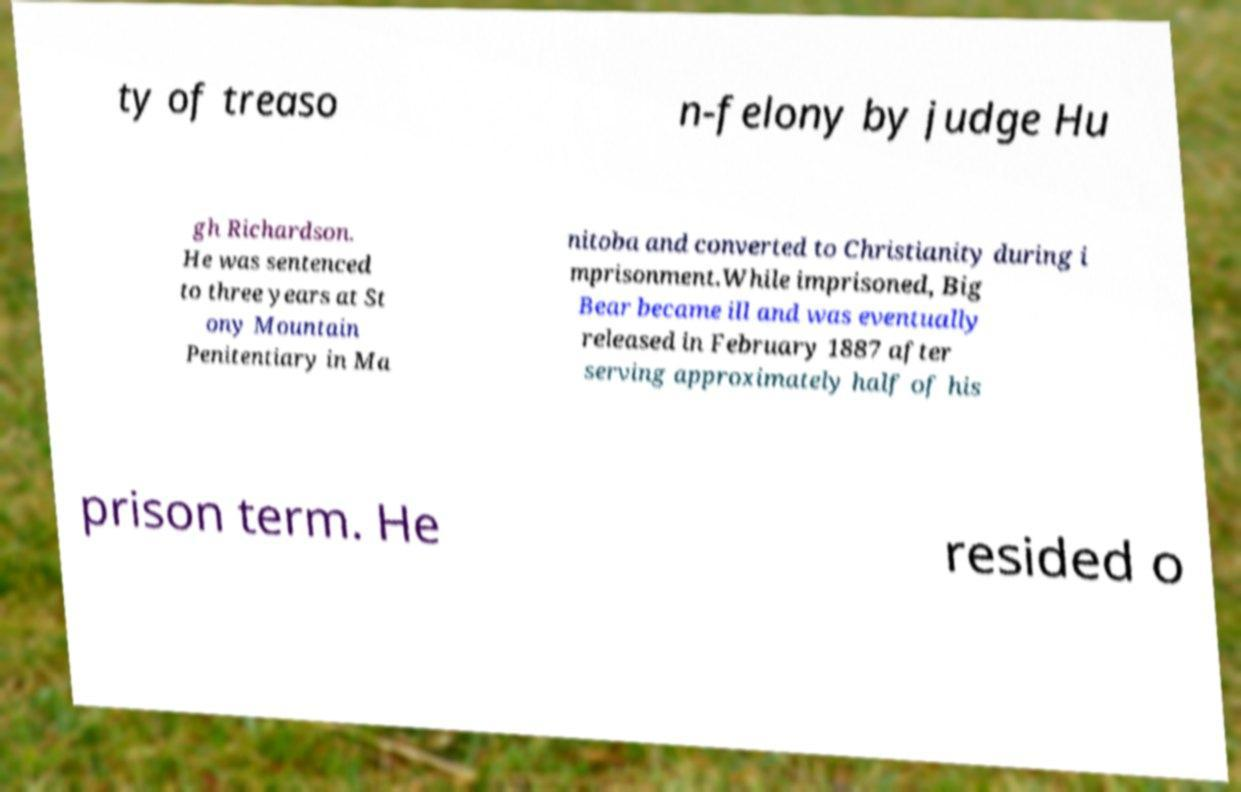Can you read and provide the text displayed in the image?This photo seems to have some interesting text. Can you extract and type it out for me? ty of treaso n-felony by judge Hu gh Richardson. He was sentenced to three years at St ony Mountain Penitentiary in Ma nitoba and converted to Christianity during i mprisonment.While imprisoned, Big Bear became ill and was eventually released in February 1887 after serving approximately half of his prison term. He resided o 